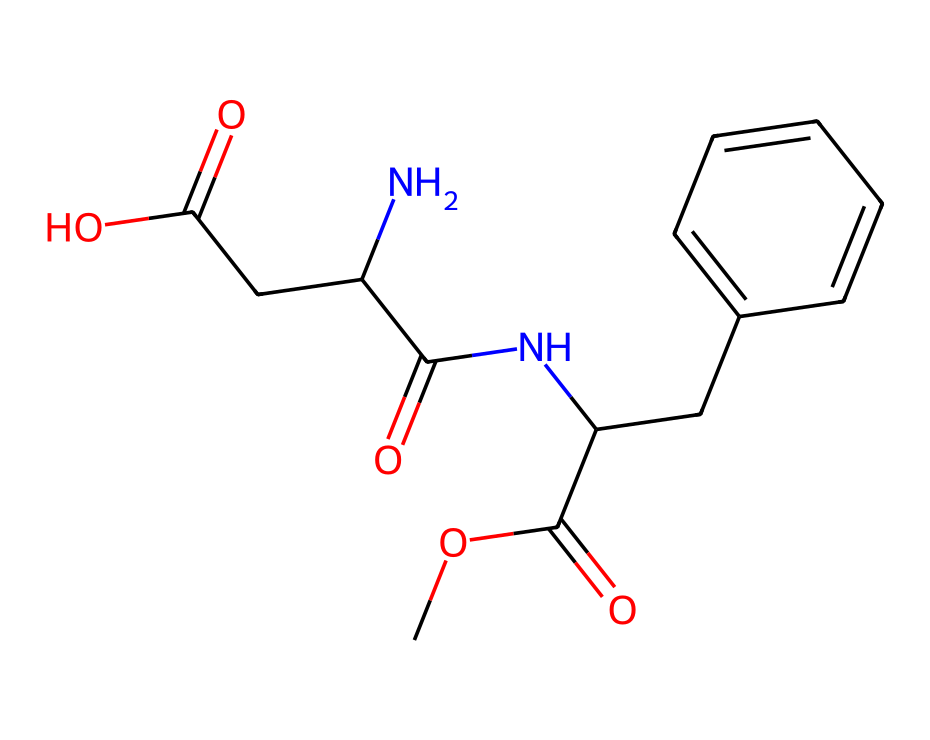How many carbon atoms are in aspartame? To find the number of carbon atoms, I can identify each 'C' in the SMILES representation. In this case, there are a total of 9 'C' characters present representing distinct carbon atoms.
Answer: 9 What types of functional groups are present in aspartame? By analyzing the structure in the SMILES, I can see multiple functional groups: an ester (COC(=O)), an amide (C(=O)N), and carboxylic acids (C(=O)O). These functional groups contribute to its characteristics as a sweetener.
Answer: ester, amide, carboxylic acid Is aspartame composed of any nitrogen atoms? Looking at the SMILES, I can spot one 'N' character, indicating there is one nitrogen atom present in the structure of aspartame.
Answer: yes What is the total number of oxygen atoms in aspartame? To determine the number of oxygen atoms, I look for 'O' in the SMILES representation. There are three 'O' characters, indicating three oxygen atoms are present in the molecule.
Answer: 3 What is the primary reason aspartame is used as a food additive? Aspartame is an artificial sweetener, primarily supplying sweetness without significant calories, which is its key characteristic and reason for use in food products.
Answer: sweetness How does the structure of aspartame affect its sweetness? The presence of specific functional groups such as the amide and ester bonds in the structure contributes to its ability to activate sweet taste receptors, making it sweeter than sucrose.
Answer: functional groups What is the molecular weight of aspartame? By calculating from the number of each type of atom in aspartame's structure (C, H, N, O) and their respective atomic weights, the molecular weight is found to be 294.3 grams per mole.
Answer: 294.3 